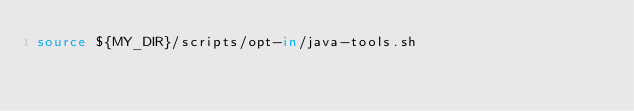<code> <loc_0><loc_0><loc_500><loc_500><_Bash_>source ${MY_DIR}/scripts/opt-in/java-tools.sh
</code> 